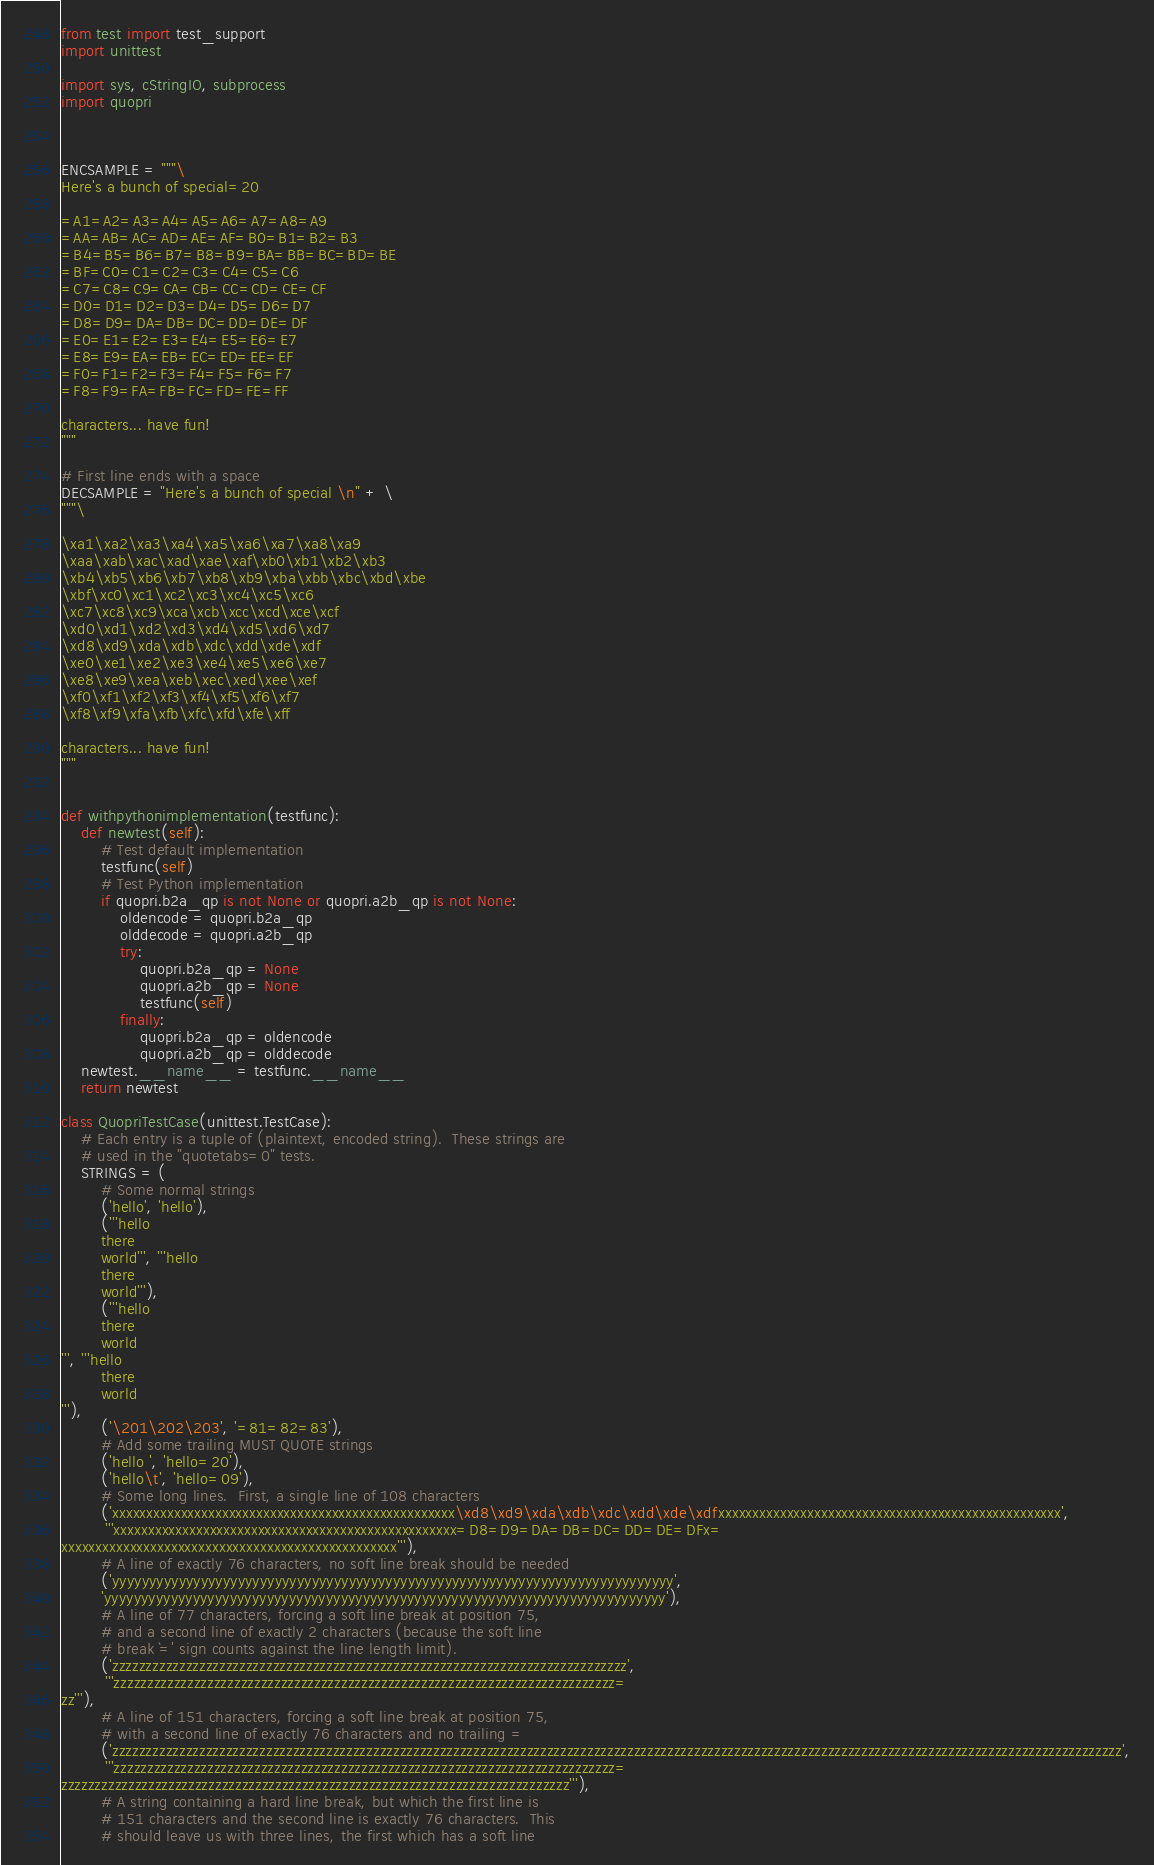<code> <loc_0><loc_0><loc_500><loc_500><_Python_>from test import test_support
import unittest

import sys, cStringIO, subprocess
import quopri



ENCSAMPLE = """\
Here's a bunch of special=20

=A1=A2=A3=A4=A5=A6=A7=A8=A9
=AA=AB=AC=AD=AE=AF=B0=B1=B2=B3
=B4=B5=B6=B7=B8=B9=BA=BB=BC=BD=BE
=BF=C0=C1=C2=C3=C4=C5=C6
=C7=C8=C9=CA=CB=CC=CD=CE=CF
=D0=D1=D2=D3=D4=D5=D6=D7
=D8=D9=DA=DB=DC=DD=DE=DF
=E0=E1=E2=E3=E4=E5=E6=E7
=E8=E9=EA=EB=EC=ED=EE=EF
=F0=F1=F2=F3=F4=F5=F6=F7
=F8=F9=FA=FB=FC=FD=FE=FF

characters... have fun!
"""

# First line ends with a space
DECSAMPLE = "Here's a bunch of special \n" + \
"""\

\xa1\xa2\xa3\xa4\xa5\xa6\xa7\xa8\xa9
\xaa\xab\xac\xad\xae\xaf\xb0\xb1\xb2\xb3
\xb4\xb5\xb6\xb7\xb8\xb9\xba\xbb\xbc\xbd\xbe
\xbf\xc0\xc1\xc2\xc3\xc4\xc5\xc6
\xc7\xc8\xc9\xca\xcb\xcc\xcd\xce\xcf
\xd0\xd1\xd2\xd3\xd4\xd5\xd6\xd7
\xd8\xd9\xda\xdb\xdc\xdd\xde\xdf
\xe0\xe1\xe2\xe3\xe4\xe5\xe6\xe7
\xe8\xe9\xea\xeb\xec\xed\xee\xef
\xf0\xf1\xf2\xf3\xf4\xf5\xf6\xf7
\xf8\xf9\xfa\xfb\xfc\xfd\xfe\xff

characters... have fun!
"""


def withpythonimplementation(testfunc):
    def newtest(self):
        # Test default implementation
        testfunc(self)
        # Test Python implementation
        if quopri.b2a_qp is not None or quopri.a2b_qp is not None:
            oldencode = quopri.b2a_qp
            olddecode = quopri.a2b_qp
            try:
                quopri.b2a_qp = None
                quopri.a2b_qp = None
                testfunc(self)
            finally:
                quopri.b2a_qp = oldencode
                quopri.a2b_qp = olddecode
    newtest.__name__ = testfunc.__name__
    return newtest

class QuopriTestCase(unittest.TestCase):
    # Each entry is a tuple of (plaintext, encoded string).  These strings are
    # used in the "quotetabs=0" tests.
    STRINGS = (
        # Some normal strings
        ('hello', 'hello'),
        ('''hello
        there
        world''', '''hello
        there
        world'''),
        ('''hello
        there
        world
''', '''hello
        there
        world
'''),
        ('\201\202\203', '=81=82=83'),
        # Add some trailing MUST QUOTE strings
        ('hello ', 'hello=20'),
        ('hello\t', 'hello=09'),
        # Some long lines.  First, a single line of 108 characters
        ('xxxxxxxxxxxxxxxxxxxxxxxxxxxxxxxxxxxxxxxxxxxxxxxxxx\xd8\xd9\xda\xdb\xdc\xdd\xde\xdfxxxxxxxxxxxxxxxxxxxxxxxxxxxxxxxxxxxxxxxxxxxxxxxxxx',
         '''xxxxxxxxxxxxxxxxxxxxxxxxxxxxxxxxxxxxxxxxxxxxxxxxxx=D8=D9=DA=DB=DC=DD=DE=DFx=
xxxxxxxxxxxxxxxxxxxxxxxxxxxxxxxxxxxxxxxxxxxxxxxxx'''),
        # A line of exactly 76 characters, no soft line break should be needed
        ('yyyyyyyyyyyyyyyyyyyyyyyyyyyyyyyyyyyyyyyyyyyyyyyyyyyyyyyyyyyyyyyyyyyyyyyyyyyy',
        'yyyyyyyyyyyyyyyyyyyyyyyyyyyyyyyyyyyyyyyyyyyyyyyyyyyyyyyyyyyyyyyyyyyyyyyyyyyy'),
        # A line of 77 characters, forcing a soft line break at position 75,
        # and a second line of exactly 2 characters (because the soft line
        # break `=' sign counts against the line length limit).
        ('zzzzzzzzzzzzzzzzzzzzzzzzzzzzzzzzzzzzzzzzzzzzzzzzzzzzzzzzzzzzzzzzzzzzzzzzzzzzz',
         '''zzzzzzzzzzzzzzzzzzzzzzzzzzzzzzzzzzzzzzzzzzzzzzzzzzzzzzzzzzzzzzzzzzzzzzzzzzz=
zz'''),
        # A line of 151 characters, forcing a soft line break at position 75,
        # with a second line of exactly 76 characters and no trailing =
        ('zzzzzzzzzzzzzzzzzzzzzzzzzzzzzzzzzzzzzzzzzzzzzzzzzzzzzzzzzzzzzzzzzzzzzzzzzzzzzzzzzzzzzzzzzzzzzzzzzzzzzzzzzzzzzzzzzzzzzzzzzzzzzzzzzzzzzzzzzzzzzzzzzzzzzzz',
         '''zzzzzzzzzzzzzzzzzzzzzzzzzzzzzzzzzzzzzzzzzzzzzzzzzzzzzzzzzzzzzzzzzzzzzzzzzzz=
zzzzzzzzzzzzzzzzzzzzzzzzzzzzzzzzzzzzzzzzzzzzzzzzzzzzzzzzzzzzzzzzzzzzzzzzzzzz'''),
        # A string containing a hard line break, but which the first line is
        # 151 characters and the second line is exactly 76 characters.  This
        # should leave us with three lines, the first which has a soft line</code> 